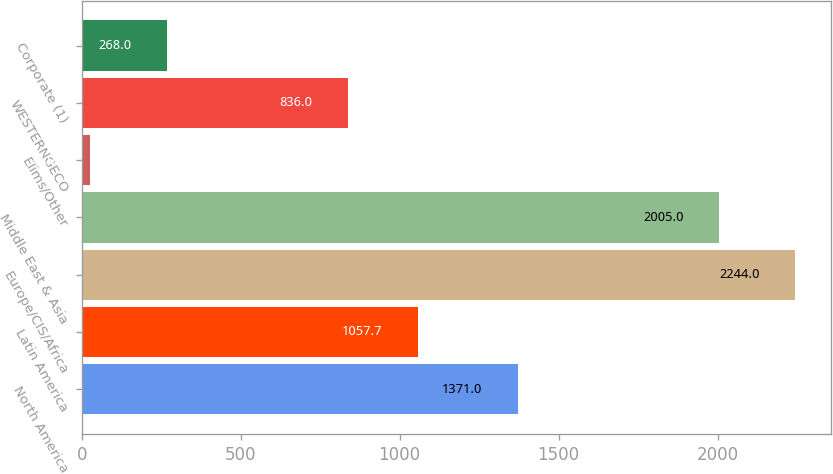Convert chart to OTSL. <chart><loc_0><loc_0><loc_500><loc_500><bar_chart><fcel>North America<fcel>Latin America<fcel>Europe/CIS/Africa<fcel>Middle East & Asia<fcel>Elims/Other<fcel>WESTERNGECO<fcel>Corporate (1)<nl><fcel>1371<fcel>1057.7<fcel>2244<fcel>2005<fcel>27<fcel>836<fcel>268<nl></chart> 